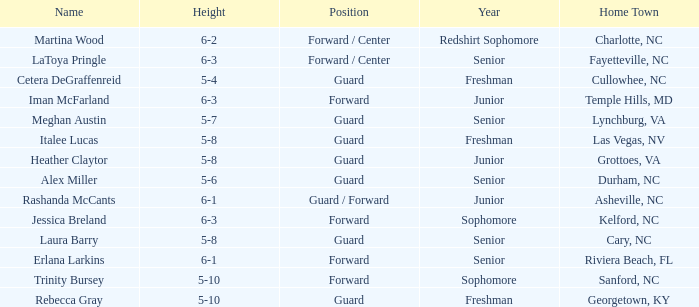What is the name of the guard from Cary, NC? Laura Barry. 